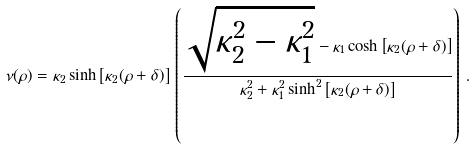<formula> <loc_0><loc_0><loc_500><loc_500>\nu ( \rho ) = \kappa _ { 2 } \sinh \left [ \kappa _ { 2 } ( \rho + \delta ) \right ] \, \left ( \frac { \sqrt { \kappa _ { 2 } ^ { 2 } - \kappa _ { 1 } ^ { 2 } } - \kappa _ { 1 } \cosh \left [ \kappa _ { 2 } ( \rho + \delta ) \right ] } { \kappa _ { 2 } ^ { 2 } + \kappa _ { 1 } ^ { 2 } \sinh ^ { 2 } \left [ \kappa _ { 2 } ( \rho + \delta ) \right ] } \right ) \, .</formula> 